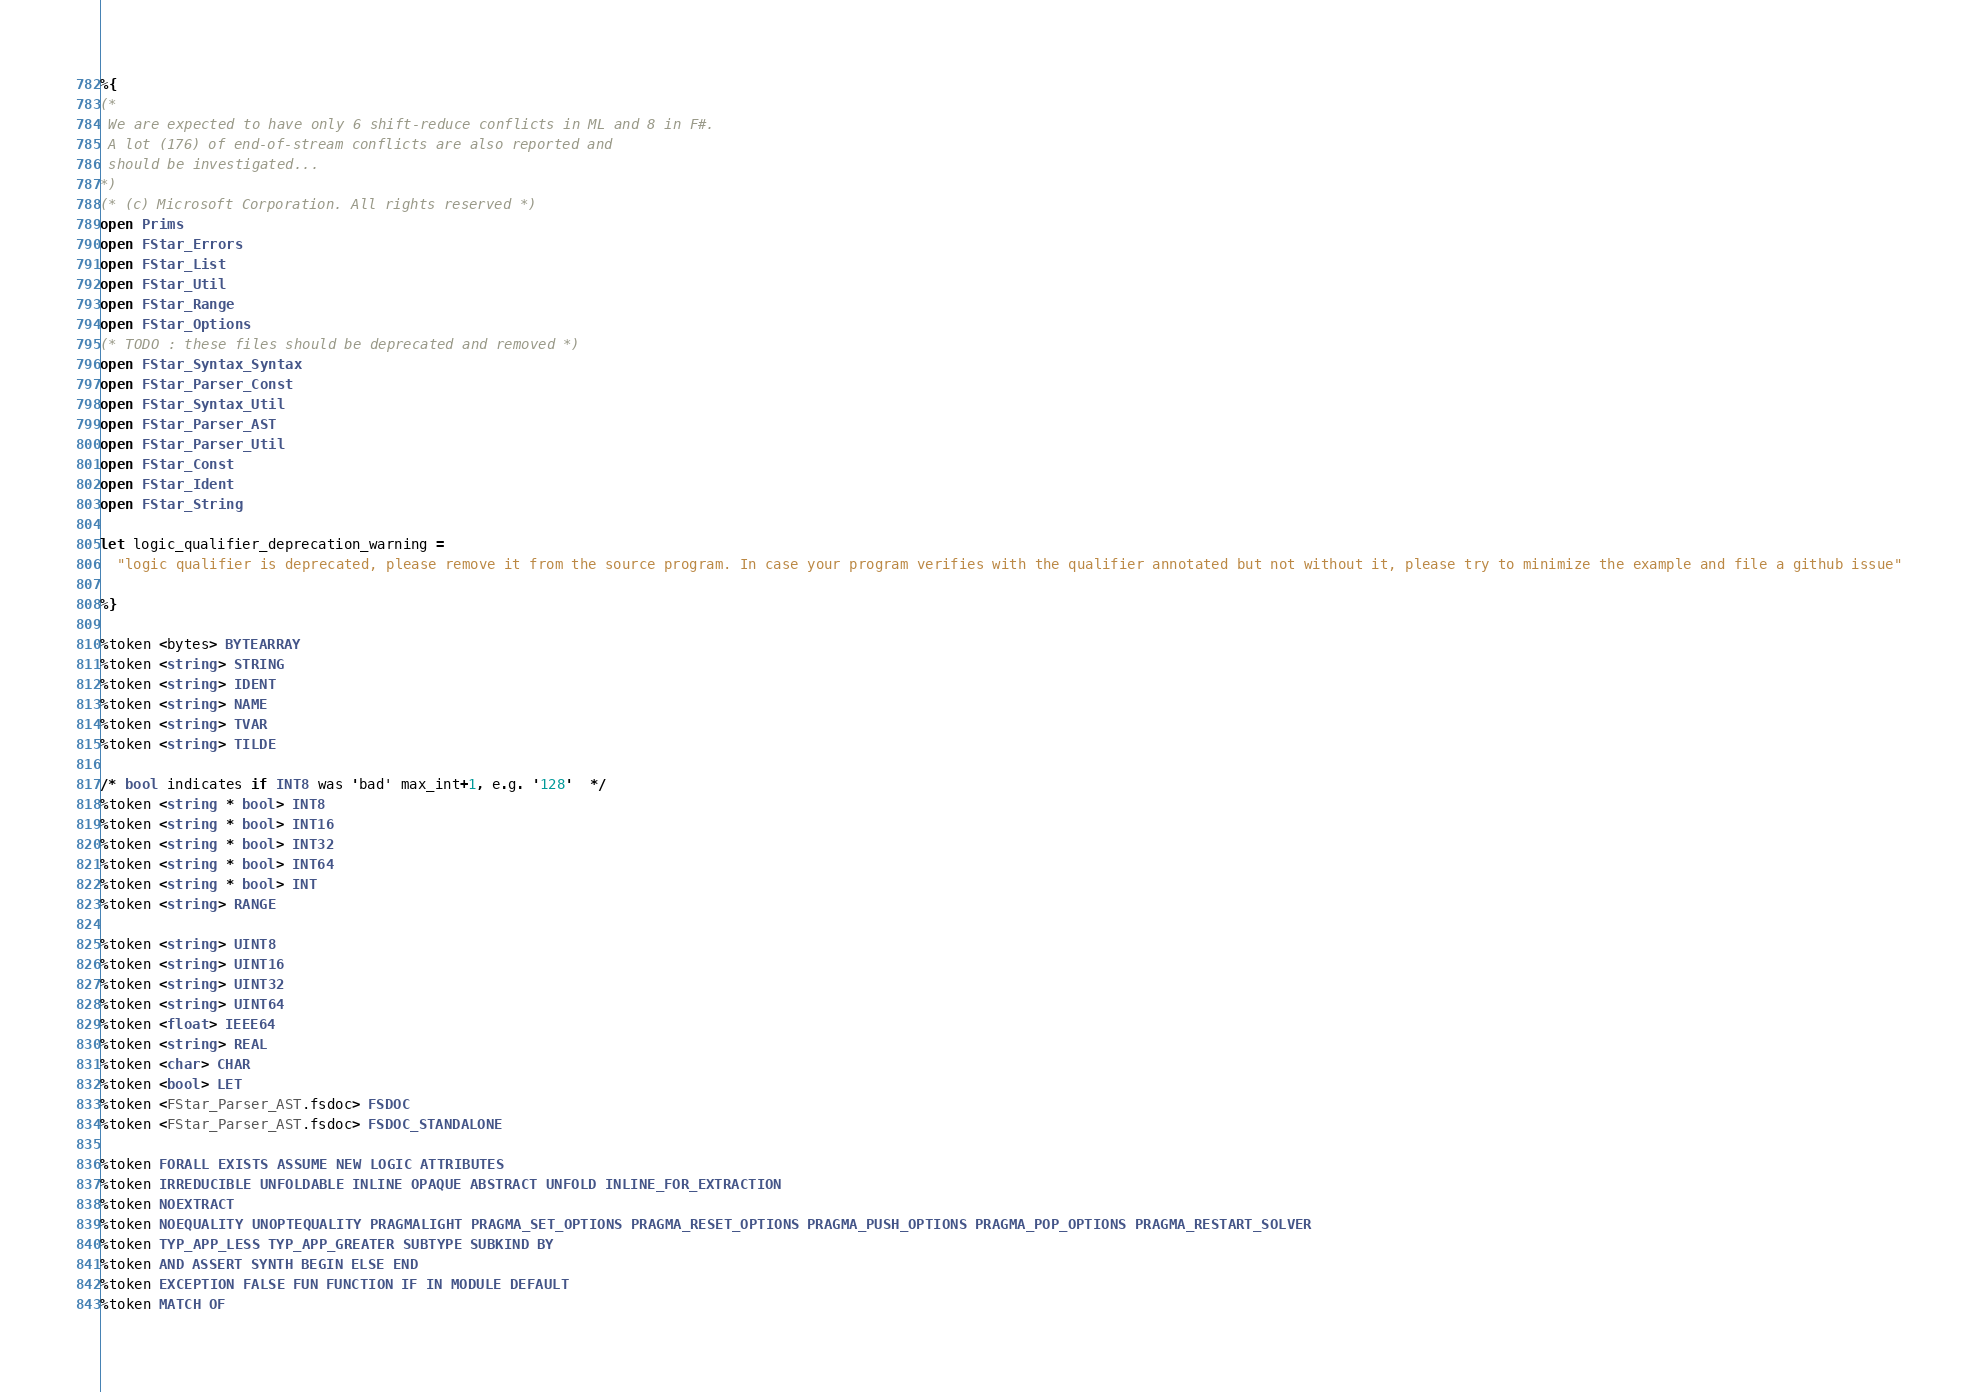Convert code to text. <code><loc_0><loc_0><loc_500><loc_500><_OCaml_>%{
(*
 We are expected to have only 6 shift-reduce conflicts in ML and 8 in F#.
 A lot (176) of end-of-stream conflicts are also reported and
 should be investigated...
*)
(* (c) Microsoft Corporation. All rights reserved *)
open Prims
open FStar_Errors
open FStar_List
open FStar_Util
open FStar_Range
open FStar_Options
(* TODO : these files should be deprecated and removed *)
open FStar_Syntax_Syntax
open FStar_Parser_Const
open FStar_Syntax_Util
open FStar_Parser_AST
open FStar_Parser_Util
open FStar_Const
open FStar_Ident
open FStar_String

let logic_qualifier_deprecation_warning =
  "logic qualifier is deprecated, please remove it from the source program. In case your program verifies with the qualifier annotated but not without it, please try to minimize the example and file a github issue"

%}

%token <bytes> BYTEARRAY
%token <string> STRING
%token <string> IDENT
%token <string> NAME
%token <string> TVAR
%token <string> TILDE

/* bool indicates if INT8 was 'bad' max_int+1, e.g. '128'  */
%token <string * bool> INT8
%token <string * bool> INT16
%token <string * bool> INT32
%token <string * bool> INT64
%token <string * bool> INT
%token <string> RANGE

%token <string> UINT8
%token <string> UINT16
%token <string> UINT32
%token <string> UINT64
%token <float> IEEE64
%token <string> REAL
%token <char> CHAR
%token <bool> LET
%token <FStar_Parser_AST.fsdoc> FSDOC
%token <FStar_Parser_AST.fsdoc> FSDOC_STANDALONE

%token FORALL EXISTS ASSUME NEW LOGIC ATTRIBUTES
%token IRREDUCIBLE UNFOLDABLE INLINE OPAQUE ABSTRACT UNFOLD INLINE_FOR_EXTRACTION
%token NOEXTRACT
%token NOEQUALITY UNOPTEQUALITY PRAGMALIGHT PRAGMA_SET_OPTIONS PRAGMA_RESET_OPTIONS PRAGMA_PUSH_OPTIONS PRAGMA_POP_OPTIONS PRAGMA_RESTART_SOLVER
%token TYP_APP_LESS TYP_APP_GREATER SUBTYPE SUBKIND BY
%token AND ASSERT SYNTH BEGIN ELSE END
%token EXCEPTION FALSE FUN FUNCTION IF IN MODULE DEFAULT
%token MATCH OF</code> 